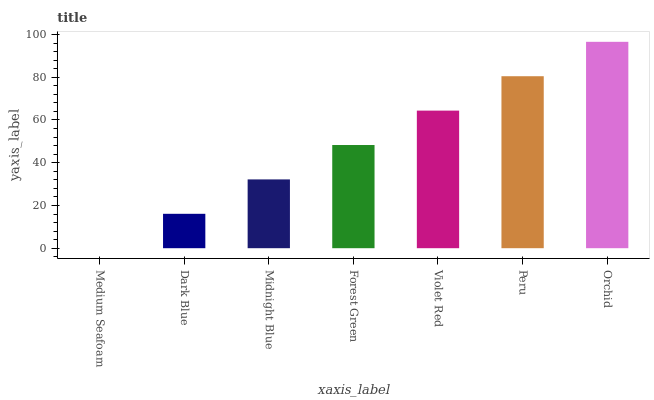Is Dark Blue the minimum?
Answer yes or no. No. Is Dark Blue the maximum?
Answer yes or no. No. Is Dark Blue greater than Medium Seafoam?
Answer yes or no. Yes. Is Medium Seafoam less than Dark Blue?
Answer yes or no. Yes. Is Medium Seafoam greater than Dark Blue?
Answer yes or no. No. Is Dark Blue less than Medium Seafoam?
Answer yes or no. No. Is Forest Green the high median?
Answer yes or no. Yes. Is Forest Green the low median?
Answer yes or no. Yes. Is Midnight Blue the high median?
Answer yes or no. No. Is Peru the low median?
Answer yes or no. No. 